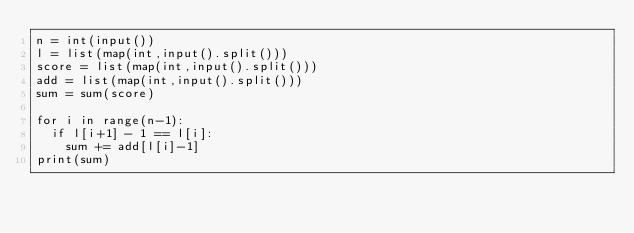Convert code to text. <code><loc_0><loc_0><loc_500><loc_500><_Python_>n = int(input())
l = list(map(int,input().split()))
score = list(map(int,input().split()))
add = list(map(int,input().split()))
sum = sum(score)

for i in range(n-1):
  if l[i+1] - 1 == l[i]:
    sum += add[l[i]-1]
print(sum)</code> 